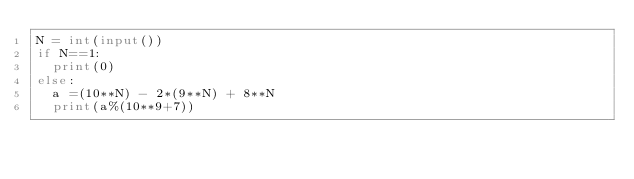Convert code to text. <code><loc_0><loc_0><loc_500><loc_500><_Python_>N = int(input())
if N==1:
  print(0)
else:
  a =(10**N) - 2*(9**N) + 8**N
  print(a%(10**9+7))</code> 